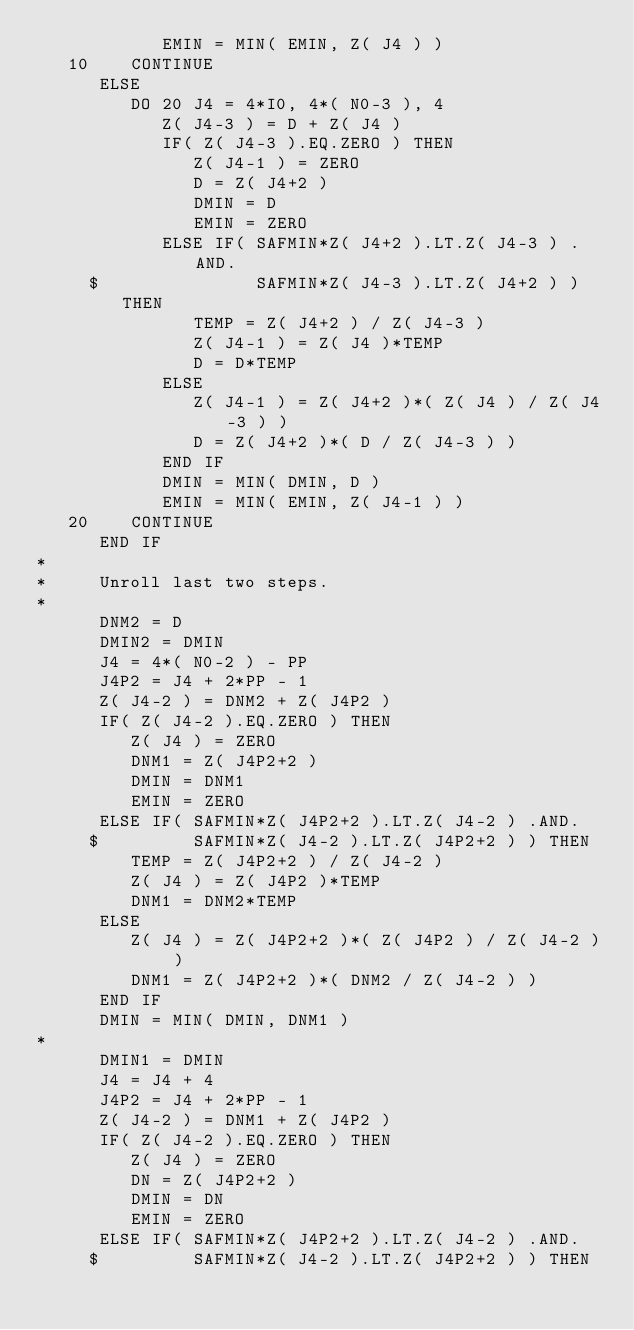<code> <loc_0><loc_0><loc_500><loc_500><_FORTRAN_>            EMIN = MIN( EMIN, Z( J4 ) )
   10    CONTINUE
      ELSE
         DO 20 J4 = 4*I0, 4*( N0-3 ), 4
            Z( J4-3 ) = D + Z( J4 ) 
            IF( Z( J4-3 ).EQ.ZERO ) THEN
               Z( J4-1 ) = ZERO
               D = Z( J4+2 )
               DMIN = D
               EMIN = ZERO
            ELSE IF( SAFMIN*Z( J4+2 ).LT.Z( J4-3 ) .AND.
     $               SAFMIN*Z( J4-3 ).LT.Z( J4+2 ) ) THEN
               TEMP = Z( J4+2 ) / Z( J4-3 )
               Z( J4-1 ) = Z( J4 )*TEMP
               D = D*TEMP
            ELSE 
               Z( J4-1 ) = Z( J4+2 )*( Z( J4 ) / Z( J4-3 ) )
               D = Z( J4+2 )*( D / Z( J4-3 ) )
            END IF
            DMIN = MIN( DMIN, D )
            EMIN = MIN( EMIN, Z( J4-1 ) )
   20    CONTINUE
      END IF
*
*     Unroll last two steps. 
*
      DNM2 = D
      DMIN2 = DMIN
      J4 = 4*( N0-2 ) - PP
      J4P2 = J4 + 2*PP - 1
      Z( J4-2 ) = DNM2 + Z( J4P2 )
      IF( Z( J4-2 ).EQ.ZERO ) THEN
         Z( J4 ) = ZERO
         DNM1 = Z( J4P2+2 )
         DMIN = DNM1
         EMIN = ZERO
      ELSE IF( SAFMIN*Z( J4P2+2 ).LT.Z( J4-2 ) .AND.
     $         SAFMIN*Z( J4-2 ).LT.Z( J4P2+2 ) ) THEN
         TEMP = Z( J4P2+2 ) / Z( J4-2 )
         Z( J4 ) = Z( J4P2 )*TEMP
         DNM1 = DNM2*TEMP
      ELSE
         Z( J4 ) = Z( J4P2+2 )*( Z( J4P2 ) / Z( J4-2 ) )
         DNM1 = Z( J4P2+2 )*( DNM2 / Z( J4-2 ) )
      END IF
      DMIN = MIN( DMIN, DNM1 )
*
      DMIN1 = DMIN
      J4 = J4 + 4
      J4P2 = J4 + 2*PP - 1
      Z( J4-2 ) = DNM1 + Z( J4P2 )
      IF( Z( J4-2 ).EQ.ZERO ) THEN
         Z( J4 ) = ZERO
         DN = Z( J4P2+2 )
         DMIN = DN
         EMIN = ZERO
      ELSE IF( SAFMIN*Z( J4P2+2 ).LT.Z( J4-2 ) .AND.
     $         SAFMIN*Z( J4-2 ).LT.Z( J4P2+2 ) ) THEN</code> 